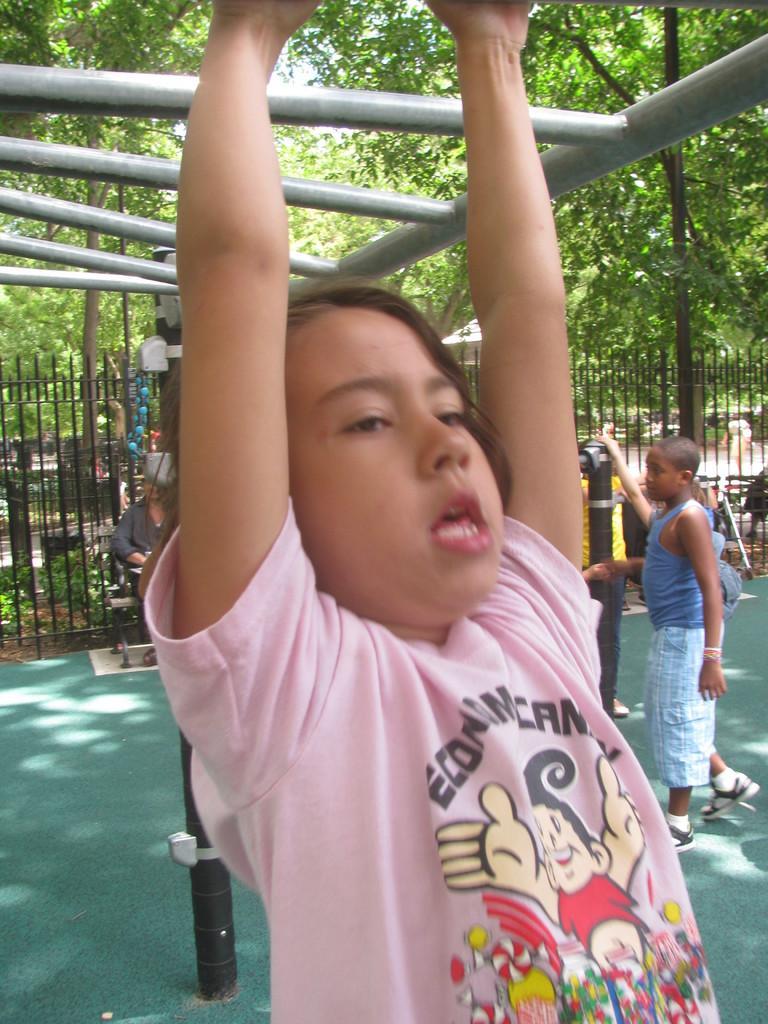In one or two sentences, can you explain what this image depicts? In this picture we can see a girl and a person sitting on a bench, fence and in the background we can see some people, trees. 